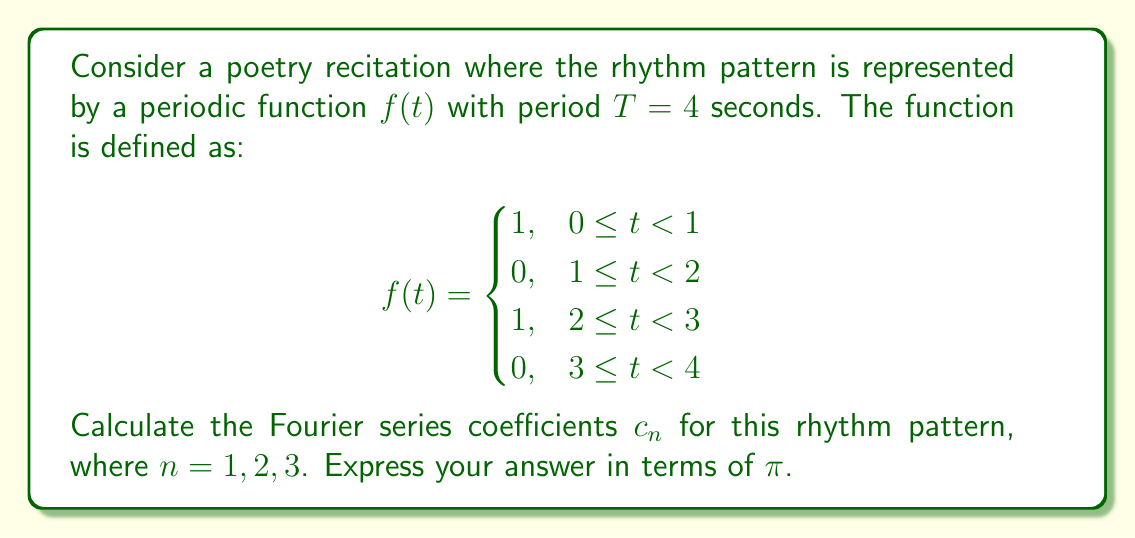Can you solve this math problem? To solve this problem, we'll use the Fourier series coefficient formula for a periodic function:

$$c_n = \frac{1}{T} \int_0^T f(t) e^{-i\omega_n t} dt$$

where $\omega_n = \frac{2\pi n}{T}$ and $T = 4$ seconds.

Step 1: Set up the integral
$$c_n = \frac{1}{4} \left(\int_0^1 e^{-i\frac{\pi n t}{2}} dt + \int_2^3 e^{-i\frac{\pi n t}{2}} dt\right)$$

Step 2: Evaluate the integrals
$$c_n = \frac{1}{4} \left[\frac{2i}{\pi n}\left(e^{-i\frac{\pi n}{2}} - 1\right) + \frac{2i}{\pi n}\left(e^{-i\frac{3\pi n}{2}} - e^{-i\pi n}\right)\right]$$

Step 3: Simplify
$$c_n = \frac{i}{2\pi n}\left(e^{-i\frac{\pi n}{2}} - 1 + e^{-i\frac{3\pi n}{2}} - e^{-i\pi n}\right)$$

Step 4: Use Euler's formula $e^{ix} = \cos x + i\sin x$
$$c_n = \frac{i}{2\pi n}\left[\left(\cos\frac{\pi n}{2} - i\sin\frac{\pi n}{2}\right) - 1 + \left(\cos\frac{3\pi n}{2} - i\sin\frac{3\pi n}{2}\right) - \left(\cos\pi n - i\sin\pi n\right)\right]$$

Step 5: Simplify further
$$c_n = \frac{1}{2\pi n}\left[2\sin\frac{\pi n}{2} - \sin\pi n\right] - \frac{i}{2\pi n}\left[2\cos\frac{\pi n}{2} - \cos\pi n - 1\right]$$

Step 6: Calculate for $n = 1, 2, 3$

For $n = 1$:
$$c_1 = \frac{1}{2\pi}\left[2\sin\frac{\pi}{2} - \sin\pi\right] - \frac{i}{2\pi}\left[2\cos\frac{\pi}{2} - \cos\pi - 1\right] = \frac{1}{\pi} - \frac{i}{\pi}$$

For $n = 2$:
$$c_2 = \frac{1}{4\pi}\left[2\sin\pi - \sin2\pi\right] - \frac{i}{4\pi}\left[2\cos\pi - \cos2\pi - 1\right] = 0$$

For $n = 3$:
$$c_3 = \frac{1}{6\pi}\left[2\sin\frac{3\pi}{2} - \sin3\pi\right] - \frac{i}{6\pi}\left[2\cos\frac{3\pi}{2} - \cos3\pi - 1\right] = -\frac{1}{3\pi} + \frac{i}{3\pi}$$
Answer: $c_1 = \frac{1}{\pi} - \frac{i}{\pi}$
$c_2 = 0$
$c_3 = -\frac{1}{3\pi} + \frac{i}{3\pi}$ 